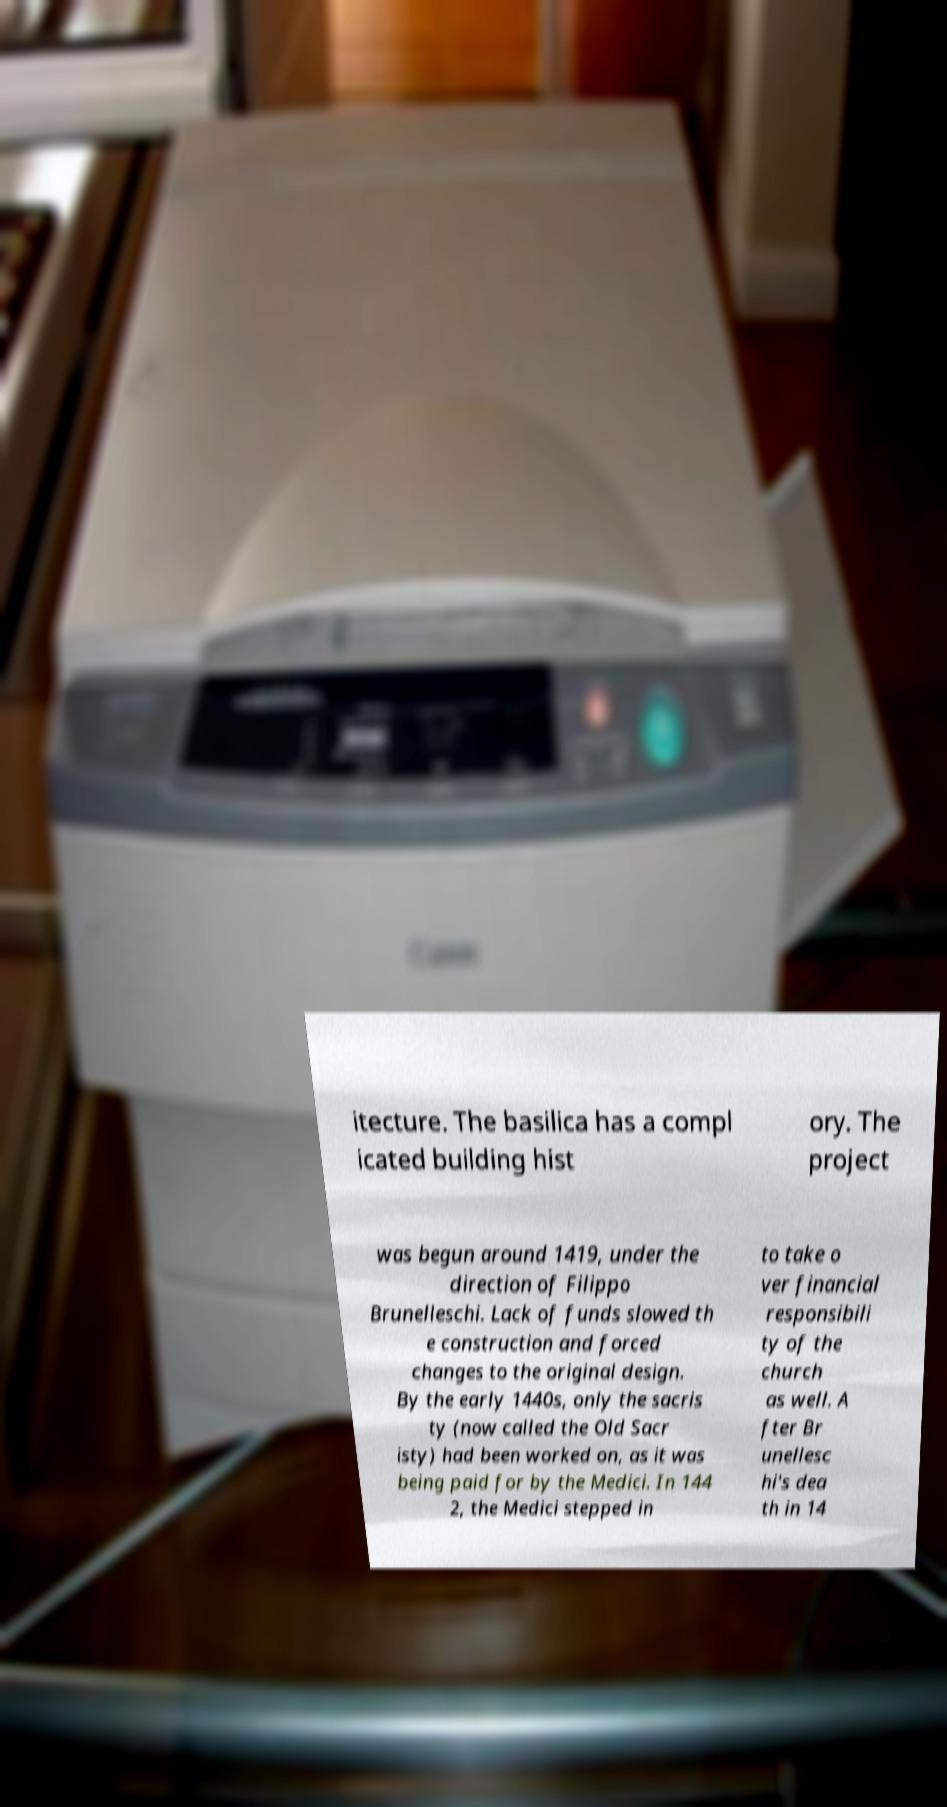What messages or text are displayed in this image? I need them in a readable, typed format. itecture. The basilica has a compl icated building hist ory. The project was begun around 1419, under the direction of Filippo Brunelleschi. Lack of funds slowed th e construction and forced changes to the original design. By the early 1440s, only the sacris ty (now called the Old Sacr isty) had been worked on, as it was being paid for by the Medici. In 144 2, the Medici stepped in to take o ver financial responsibili ty of the church as well. A fter Br unellesc hi's dea th in 14 